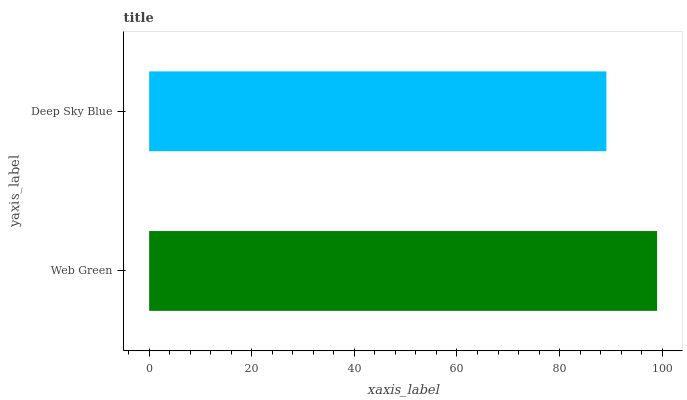Is Deep Sky Blue the minimum?
Answer yes or no. Yes. Is Web Green the maximum?
Answer yes or no. Yes. Is Deep Sky Blue the maximum?
Answer yes or no. No. Is Web Green greater than Deep Sky Blue?
Answer yes or no. Yes. Is Deep Sky Blue less than Web Green?
Answer yes or no. Yes. Is Deep Sky Blue greater than Web Green?
Answer yes or no. No. Is Web Green less than Deep Sky Blue?
Answer yes or no. No. Is Web Green the high median?
Answer yes or no. Yes. Is Deep Sky Blue the low median?
Answer yes or no. Yes. Is Deep Sky Blue the high median?
Answer yes or no. No. Is Web Green the low median?
Answer yes or no. No. 